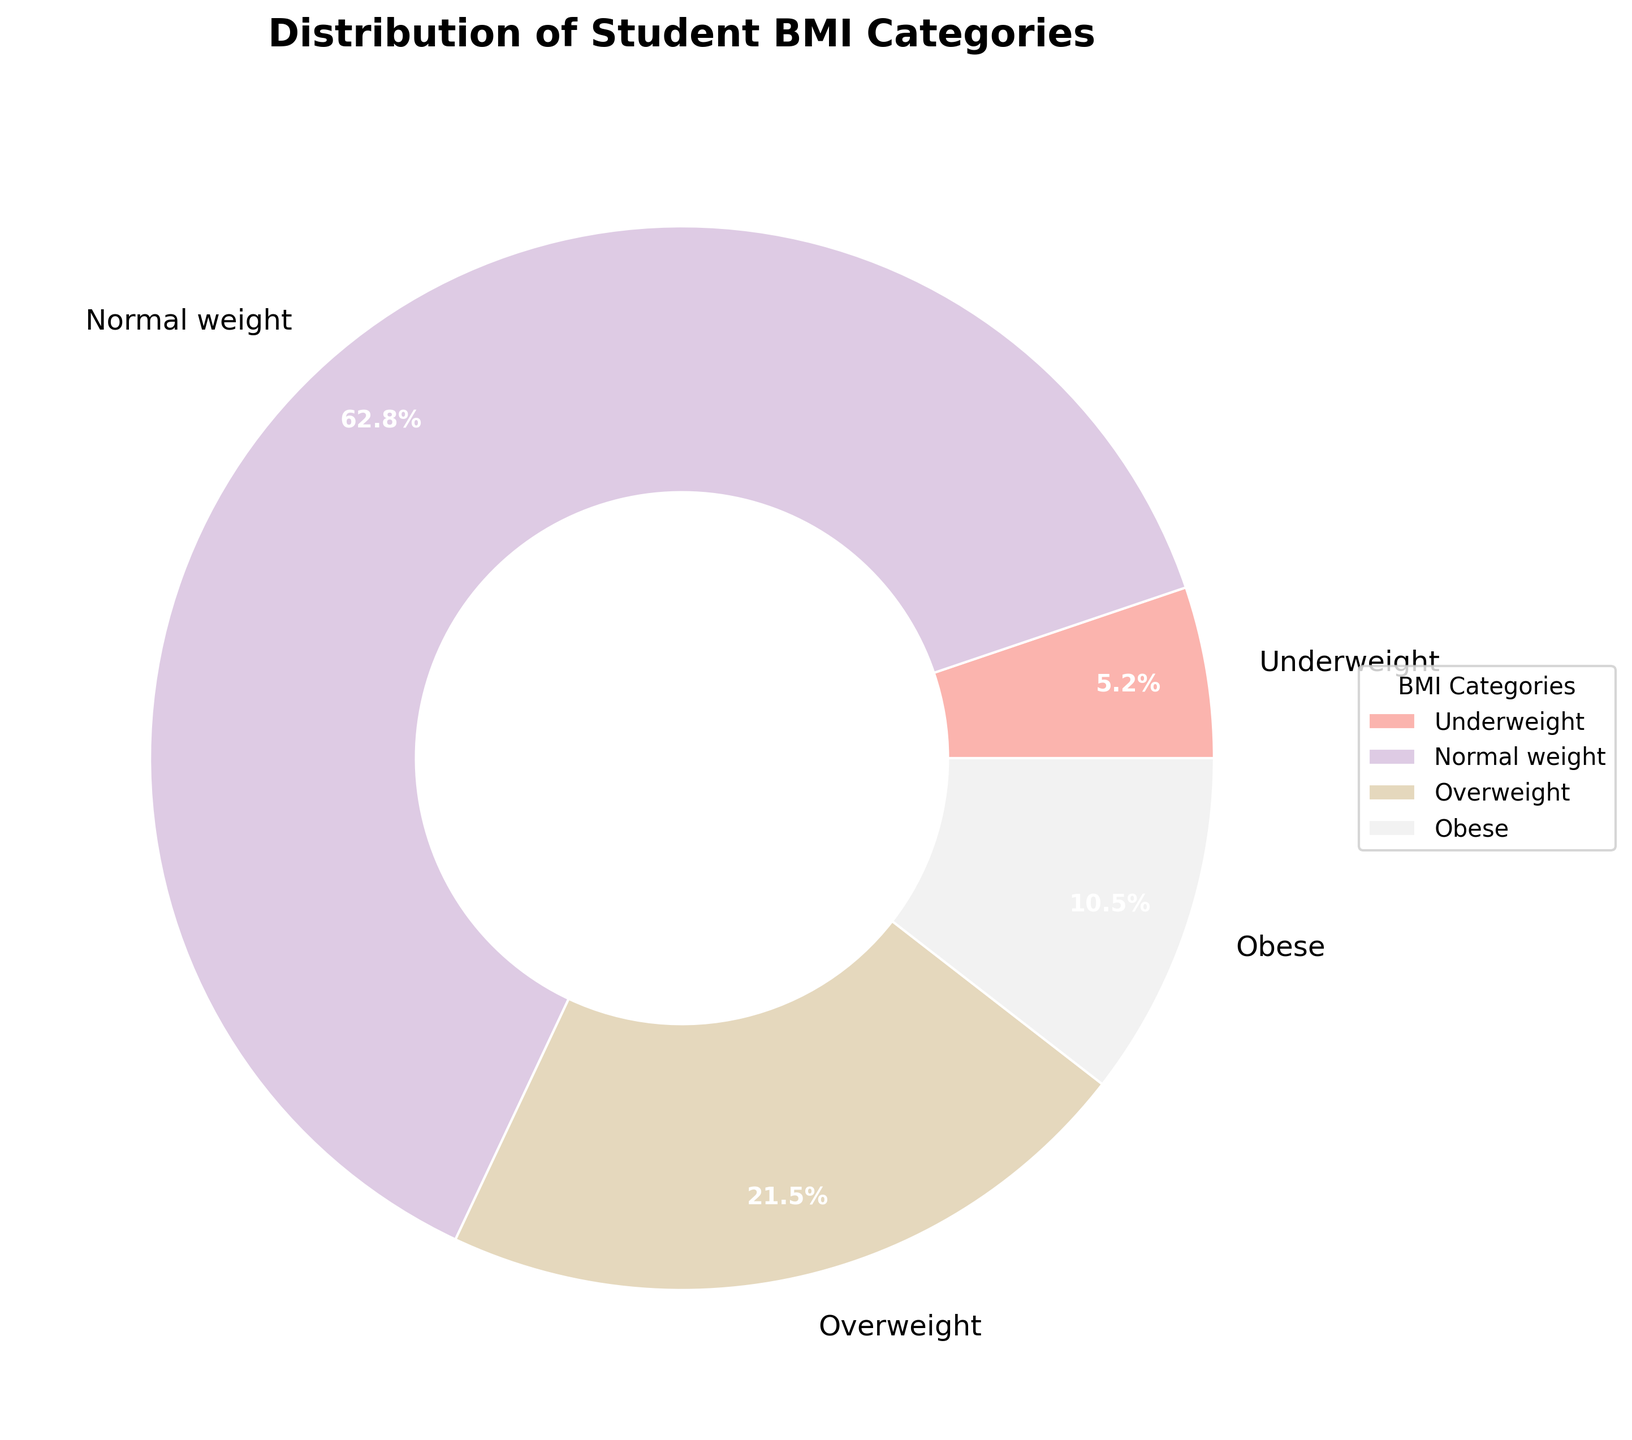What is the largest BMI category among the students? By looking at the portions within the pie chart, the largest section represents the "Normal weight" category, which also has the highest percentage shown as 62.8%.
Answer: Normal weight How many students are overweight and obese combined? First, identify the portions labeled as "Overweight" (21.5%) and "Obese" (10.5%) on the pie chart. Then, add these percentages together: 21.5% + 10.5% = 32%.
Answer: 32% Which BMI category has the smallest proportion of students? By examining the sizes of the sections in the pie chart, the "Underweight" category is the smallest, which also matches the percentage shown as 5.2%.
Answer: Underweight What is the difference in proportion between the Normal weight and Obese categories? Find the percentages for "Normal weight" (62.8%) and "Obese" (10.5%). Then, subtract the smaller percentage from the larger one: 62.8% - 10.5% = 52.3%.
Answer: 52.3% Are there more students who are overweight or underweight? Compare the pie chart portions for "Overweight" (21.5%) and "Underweight" (5.2%). The "Overweight" category clearly has a larger percentage.
Answer: Overweight What is the combined percentage of students who are underweight and normal weight? Identify the percentages for "Underweight" (5.2%) and "Normal weight" (62.8%). Add these values together: 5.2% + 62.8% = 68%.
Answer: 68% What is the visual color of the Normal weight category in the pie chart? Observe the section of the pie chart labeled "Normal weight." It is presented in one of the pastel colors, which we must associate from "Pastel1" palette visually known as a soft color.
Answer: Pastel color Which category falls between Overweight and Underweight in student proportion? Locate the segments on the pie chart. The "Obese" category (10.5%) falls between "Overweight" (21.5%) and "Underweight" (5.2%) in terms of size.
Answer: Obese 